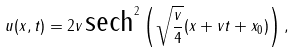Convert formula to latex. <formula><loc_0><loc_0><loc_500><loc_500>u ( x , t ) = 2 v \, \text {sech} ^ { 2 } \left ( \sqrt { \frac { v } { 4 } } ( x + v t + x _ { 0 } ) \right ) ,</formula> 